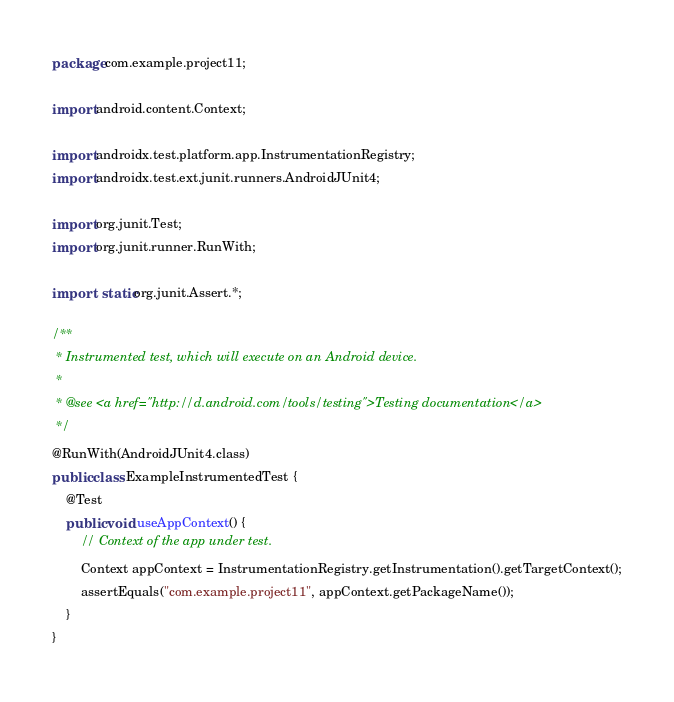Convert code to text. <code><loc_0><loc_0><loc_500><loc_500><_Java_>package com.example.project11;

import android.content.Context;

import androidx.test.platform.app.InstrumentationRegistry;
import androidx.test.ext.junit.runners.AndroidJUnit4;

import org.junit.Test;
import org.junit.runner.RunWith;

import static org.junit.Assert.*;

/**
 * Instrumented test, which will execute on an Android device.
 *
 * @see <a href="http://d.android.com/tools/testing">Testing documentation</a>
 */
@RunWith(AndroidJUnit4.class)
public class ExampleInstrumentedTest {
    @Test
    public void useAppContext() {
        // Context of the app under test.
        Context appContext = InstrumentationRegistry.getInstrumentation().getTargetContext();
        assertEquals("com.example.project11", appContext.getPackageName());
    }
}</code> 